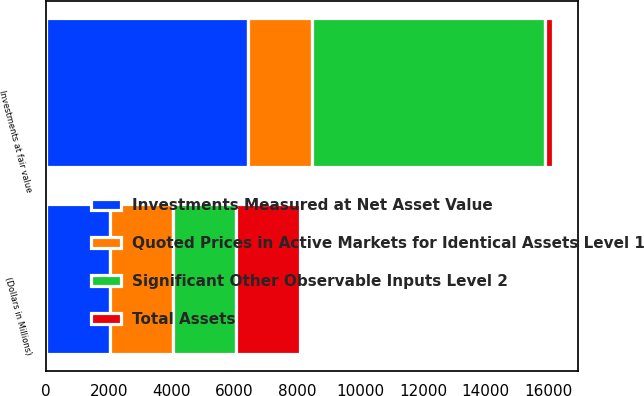<chart> <loc_0><loc_0><loc_500><loc_500><stacked_bar_chart><ecel><fcel>(Dollars in Millions)<fcel>Investments at fair value<nl><fcel>Quoted Prices in Active Markets for Identical Assets Level 1<fcel>2017<fcel>2017<nl><fcel>Significant Other Observable Inputs Level 2<fcel>2017<fcel>7435<nl><fcel>Total Assets<fcel>2017<fcel>256<nl><fcel>Investments Measured at Net Asset Value<fcel>2017<fcel>6436<nl></chart> 